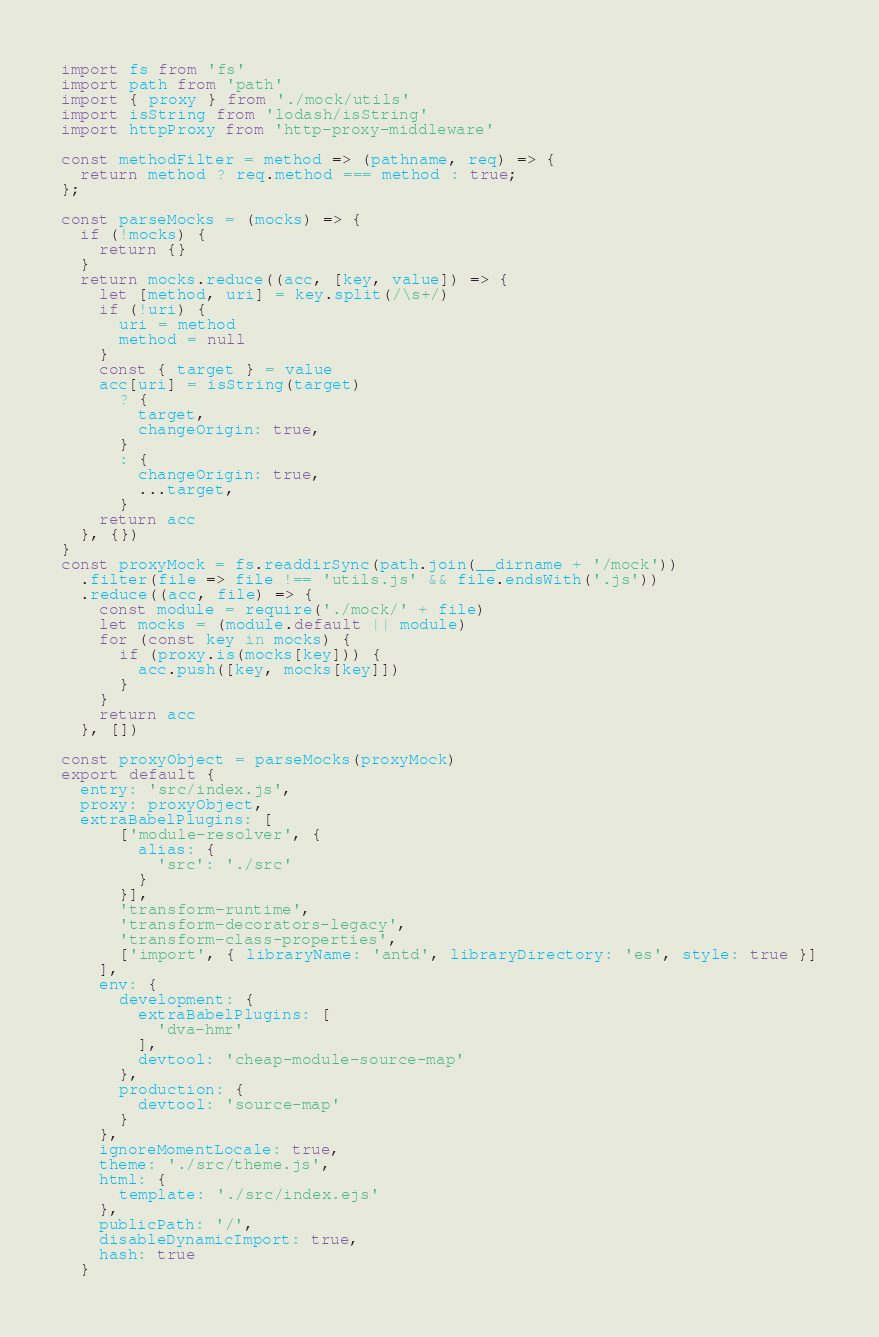Convert code to text. <code><loc_0><loc_0><loc_500><loc_500><_JavaScript_>import fs from 'fs'
import path from 'path'
import { proxy } from './mock/utils'
import isString from 'lodash/isString'
import httpProxy from 'http-proxy-middleware'

const methodFilter = method => (pathname, req) => {
  return method ? req.method === method : true;
};

const parseMocks = (mocks) => {
  if (!mocks) {
    return {}
  }
  return mocks.reduce((acc, [key, value]) => {
    let [method, uri] = key.split(/\s+/)
    if (!uri) {
      uri = method
      method = null
    }
    const { target } = value
    acc[uri] = isString(target)
      ? {
        target,
        changeOrigin: true,
      }
      : {
        changeOrigin: true,
        ...target,
      }
    return acc
  }, {})
}
const proxyMock = fs.readdirSync(path.join(__dirname + '/mock'))
  .filter(file => file !== 'utils.js' && file.endsWith('.js'))
  .reduce((acc, file) => {
    const module = require('./mock/' + file)
    let mocks = (module.default || module)
    for (const key in mocks) {
      if (proxy.is(mocks[key])) {
        acc.push([key, mocks[key]])
      }
    }
    return acc
  }, [])

const proxyObject = parseMocks(proxyMock)
export default {
  entry: 'src/index.js',
  proxy: proxyObject,
  extraBabelPlugins: [
      ['module-resolver', {
        alias: {
          'src': './src'
        }
      }],
      'transform-runtime',
      'transform-decorators-legacy',
      'transform-class-properties',
      ['import', { libraryName: 'antd', libraryDirectory: 'es', style: true }]
    ],
    env: {
      development: {
        extraBabelPlugins: [
          'dva-hmr'
        ],
        devtool: 'cheap-module-source-map'
      },
      production: {
        devtool: 'source-map'
      }
    },
    ignoreMomentLocale: true,
    theme: './src/theme.js',
    html: {
      template: './src/index.ejs'
    },
    publicPath: '/',
    disableDynamicImport: true,
    hash: true
  }
</code> 